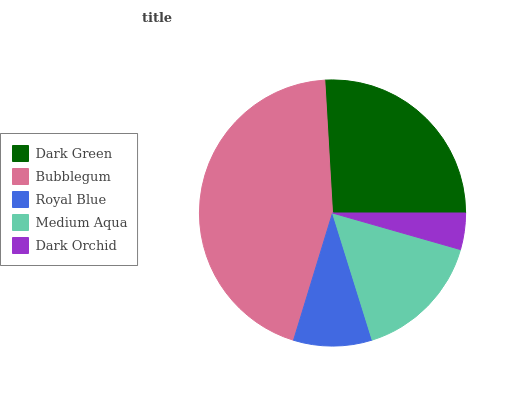Is Dark Orchid the minimum?
Answer yes or no. Yes. Is Bubblegum the maximum?
Answer yes or no. Yes. Is Royal Blue the minimum?
Answer yes or no. No. Is Royal Blue the maximum?
Answer yes or no. No. Is Bubblegum greater than Royal Blue?
Answer yes or no. Yes. Is Royal Blue less than Bubblegum?
Answer yes or no. Yes. Is Royal Blue greater than Bubblegum?
Answer yes or no. No. Is Bubblegum less than Royal Blue?
Answer yes or no. No. Is Medium Aqua the high median?
Answer yes or no. Yes. Is Medium Aqua the low median?
Answer yes or no. Yes. Is Dark Green the high median?
Answer yes or no. No. Is Bubblegum the low median?
Answer yes or no. No. 